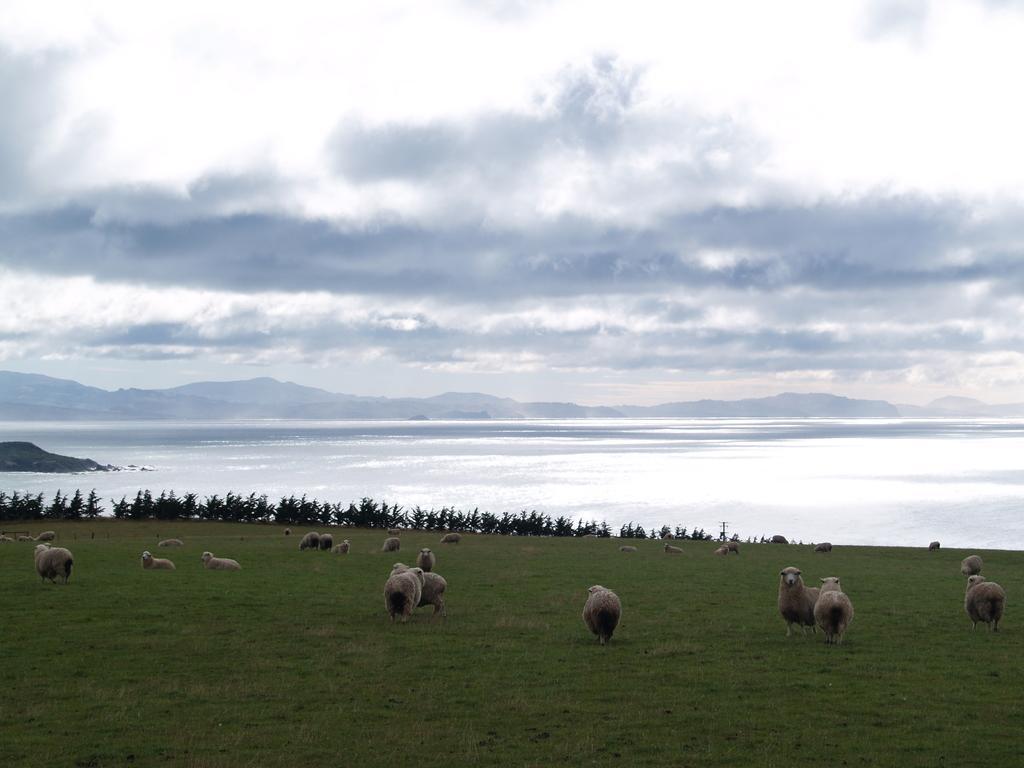How would you summarize this image in a sentence or two? In the picture we can see a grass surface on it, we can see some sheep are standing and far away from it, we can see some plants and behind it we can see water, hills and sky with clouds. 